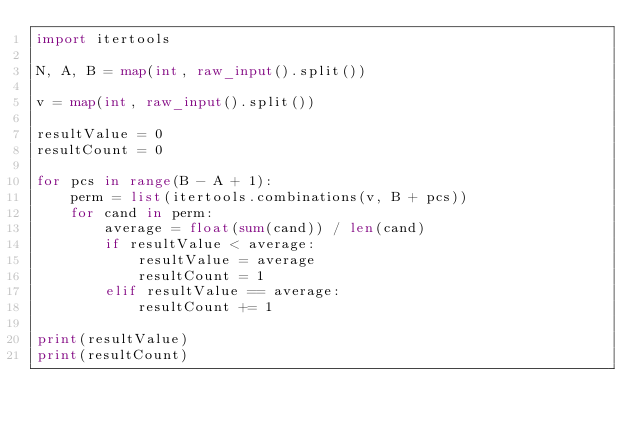Convert code to text. <code><loc_0><loc_0><loc_500><loc_500><_Python_>import itertools
 
N, A, B = map(int, raw_input().split())
 
v = map(int, raw_input().split())
 
resultValue = 0
resultCount = 0
 
for pcs in range(B - A + 1):
    perm = list(itertools.combinations(v, B + pcs))
    for cand in perm:
        average = float(sum(cand)) / len(cand)
        if resultValue < average:
            resultValue = average
            resultCount = 1
        elif resultValue == average:
            resultCount += 1
 
print(resultValue)
print(resultCount)
</code> 